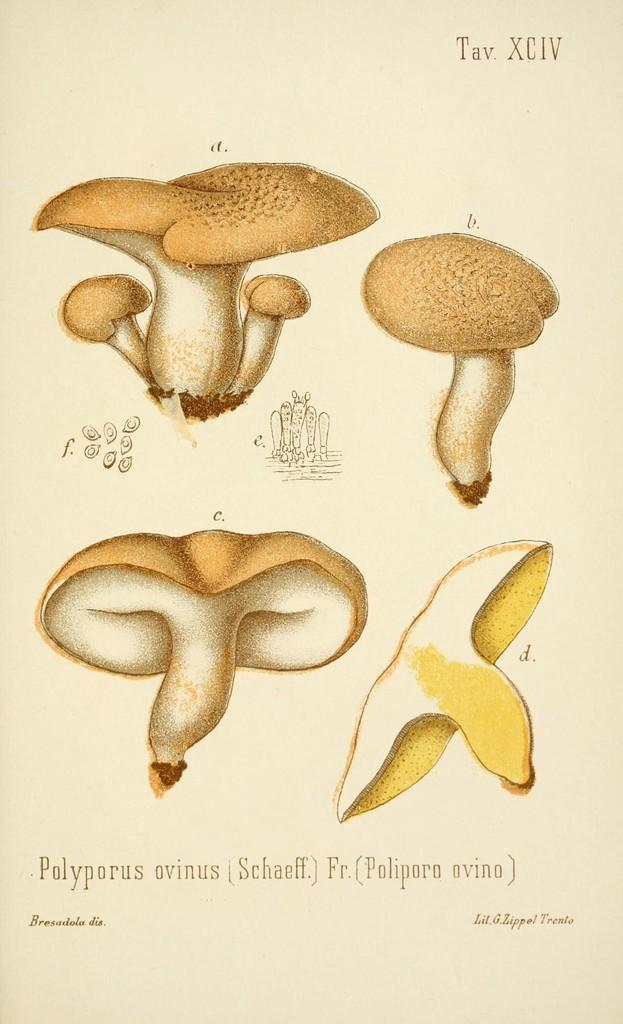What is the main subject of the pictures in the image? The main subject of the pictures in the image is mushrooms. What color is the background of the image? The background of the image is cream-colored. Where is the airport located in the image? There is no airport present in the image; it features pictures of mushrooms with a cream-colored background. What type of patch is visible on the mushrooms in the image? There are no patches visible on the mushrooms in the image; it only shows pictures of mushrooms with a cream-colored background. 